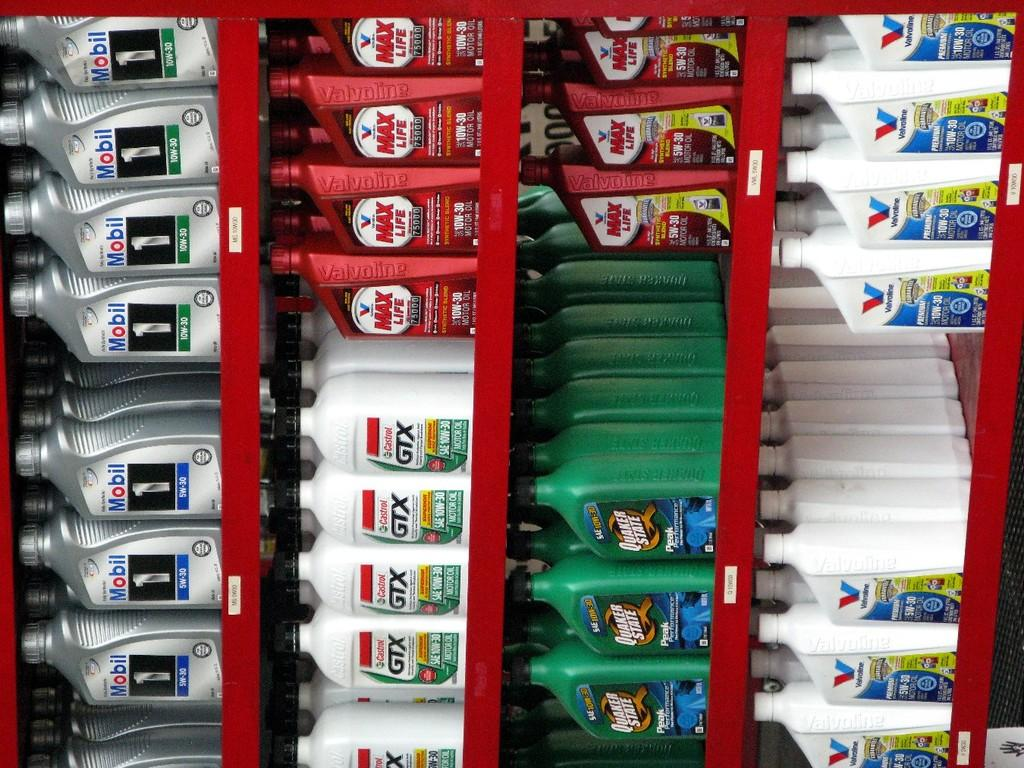<image>
Render a clear and concise summary of the photo. Several different kinds of motor oil such as Mobil, Valvoline, and Quaker State are grouped together on a red shelf. 